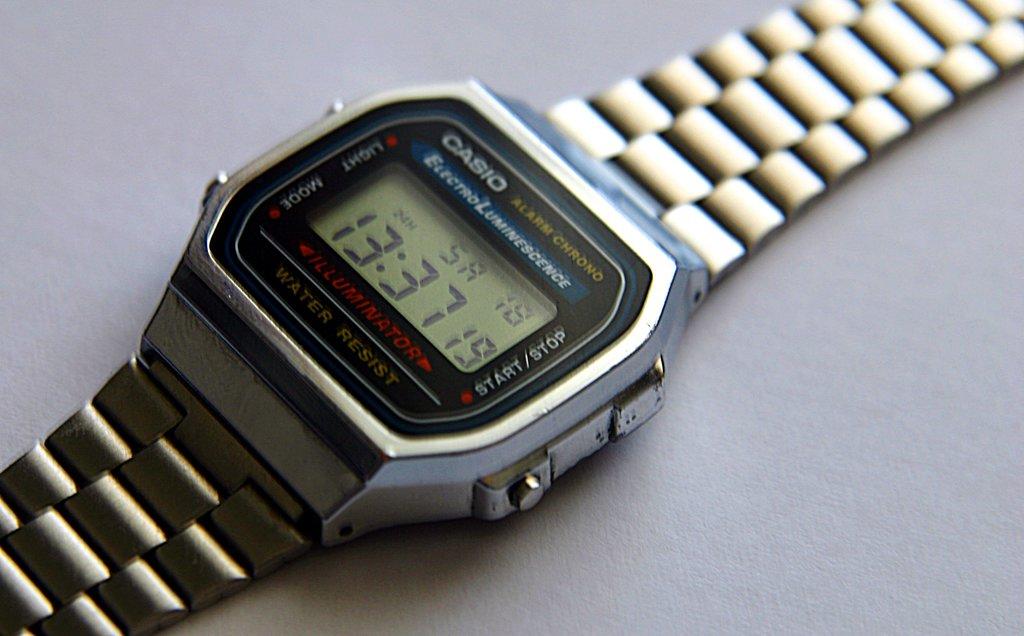What time is it?
Provide a short and direct response. 13:37. What brand of watch is this?
Keep it short and to the point. Casio. 